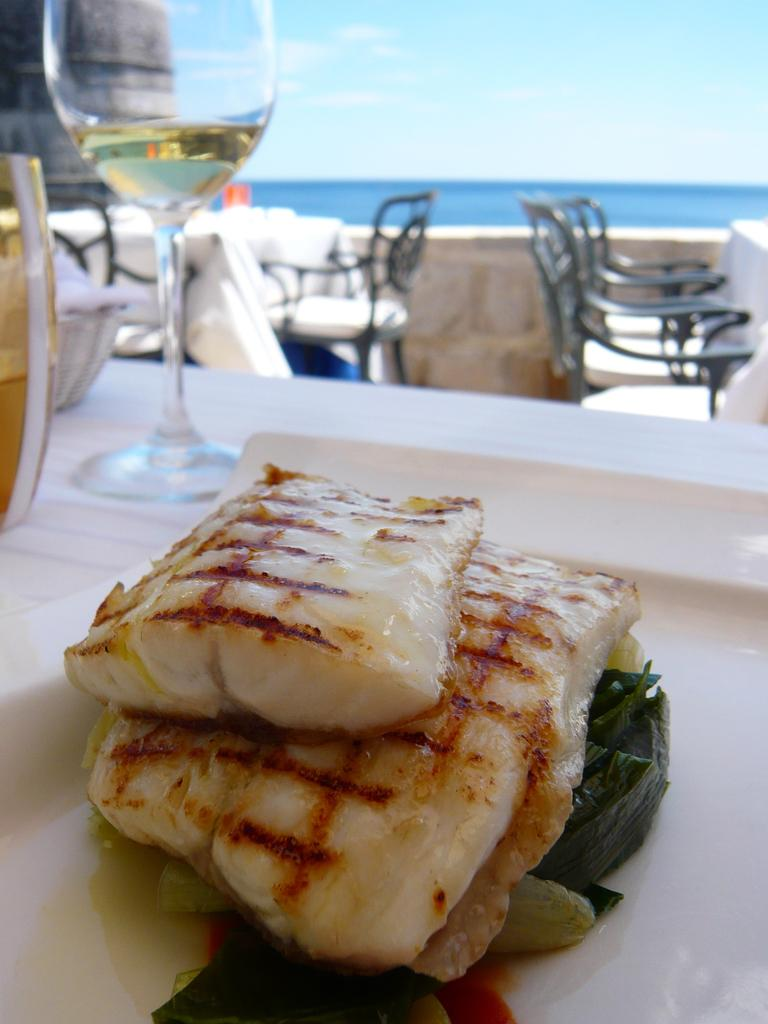What type of food is visible in the image? There is food in the image, but the specific type is not mentioned. What type of container is present in the image? There is a glass and a bowl in the image. Where are the objects located? The objects are on a table. What type of seating is visible in the background of the image? There are chairs and benches in the background of the image. What can be seen in the distance in the image? Water and the sky are visible in the background of the image. How does the self-awareness of the food in the image affect its taste? There is no indication that the food in the image is self-aware, so this question cannot be answered. What type of reward is being offered for completing the task in the image? There is no task mentioned in the image, so there is no reward being offered. 